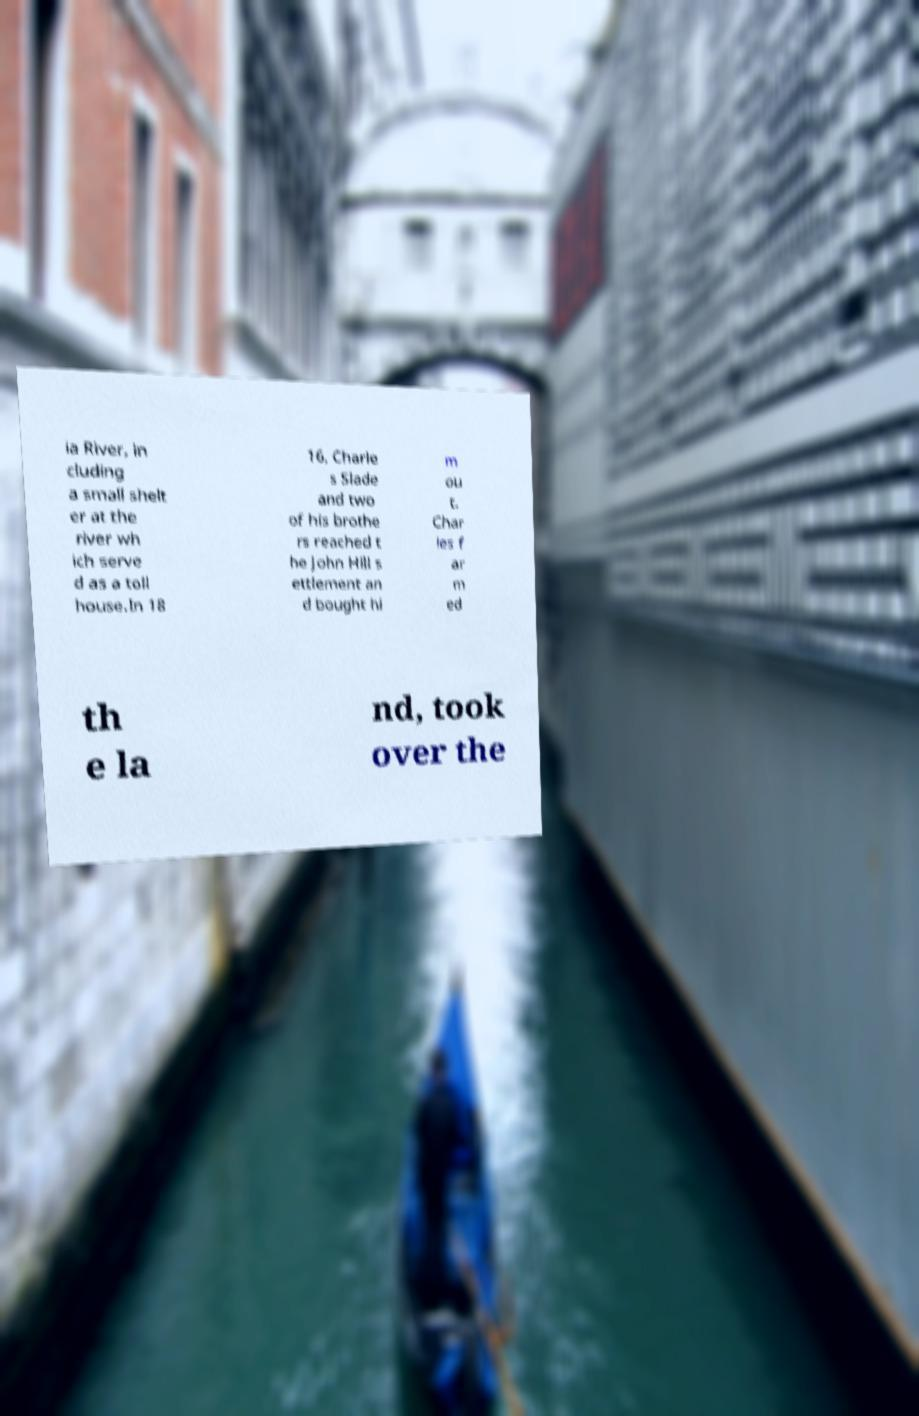There's text embedded in this image that I need extracted. Can you transcribe it verbatim? ia River, in cluding a small shelt er at the river wh ich serve d as a toll house.In 18 16, Charle s Slade and two of his brothe rs reached t he John Hill s ettlement an d bought hi m ou t. Char les f ar m ed th e la nd, took over the 